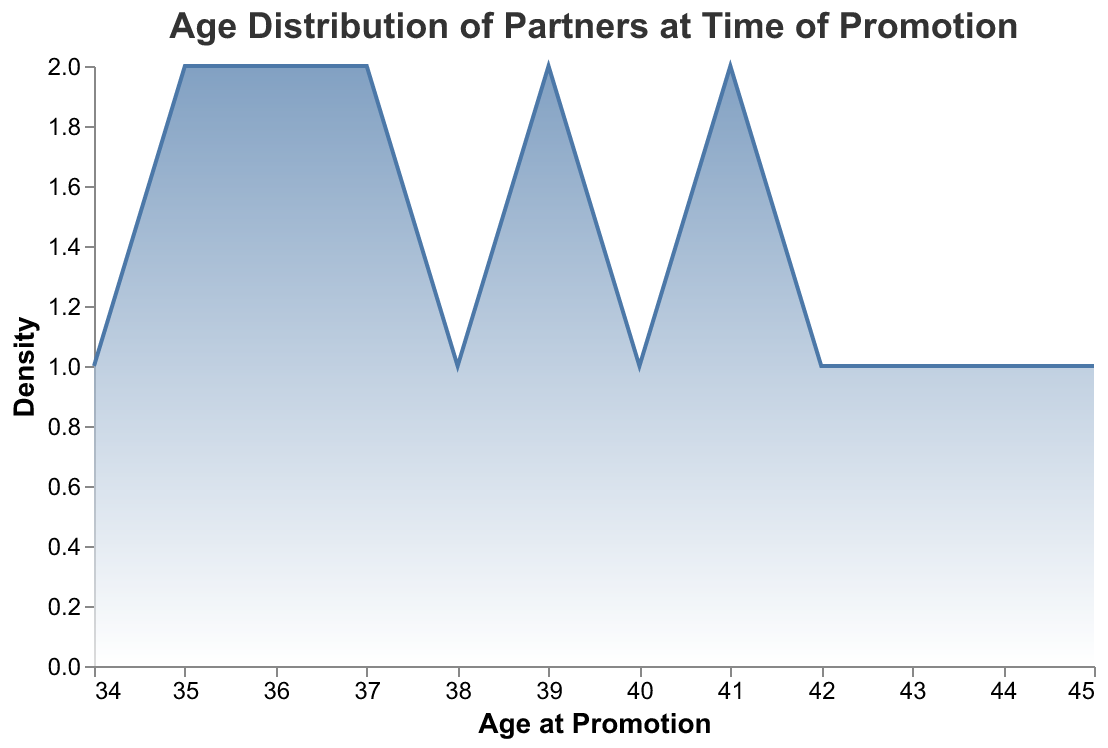what is the peak age for promotion to partner? The peak age for promotion can be observed by identifying the highest point on the density plot. This peak represents the age where the frequency of promotions is the highest.
Answer: 39 what is the title of the figure? The title of the figure is usually prominent and located at the top. It provides the theme or main focus of the plot.
Answer: Age Distribution of Partners at Time of Promotion what is the youngest age at promotion displayed in the figure? The youngest age at promotion can be identified by finding the left-most point on the x-axis. This represents the minimum age in the dataset.
Answer: 34 What is the total number of partners within the 35-40 age range? To determine this, observe the density curve between the ages of 35 and 40 and count the number of peaks and troughs. The sum will represent the total number of individuals in the specified age range.
Answer: 9 what is the difference in age at promotion between the oldest and youngest partners? To find the difference, simply subtract the youngest age at promotion from the oldest age at promotion observed on the x-axis.
Answer: 11 how many distinct firms are represented in the data? To determine the number of distinct firms, count the unique firm names associated with the partners in the dataset.
Answer: 15 What age range contains the majority of promotions? The age range containing the majority of promotions can be identified by observing where the density curve is the highest and spread out the most on the x-axis.
Answer: 35-41 is there a consistent trend in the age distribution of partners being promoted? To evaluate the consistency, observe the general shape and spread of the density curve. A consistent trend would show a smooth curve without sharp peaks and valleys.
Answer: No is the distribution of promotion ages skewed in any particular direction? Observing the balance of the density plot, if more values lie to one side of the mean or median, the distribution can be considered skewed to that side.
Answer: Slightly right-skewed Compared to other partners, how frequently are partners promoted at the age of 45? To determine this frequency, look at the value at 45 on the density plot and compare its height to other points on the plot. A lower height indicates lower frequency.
Answer: Less frequently 